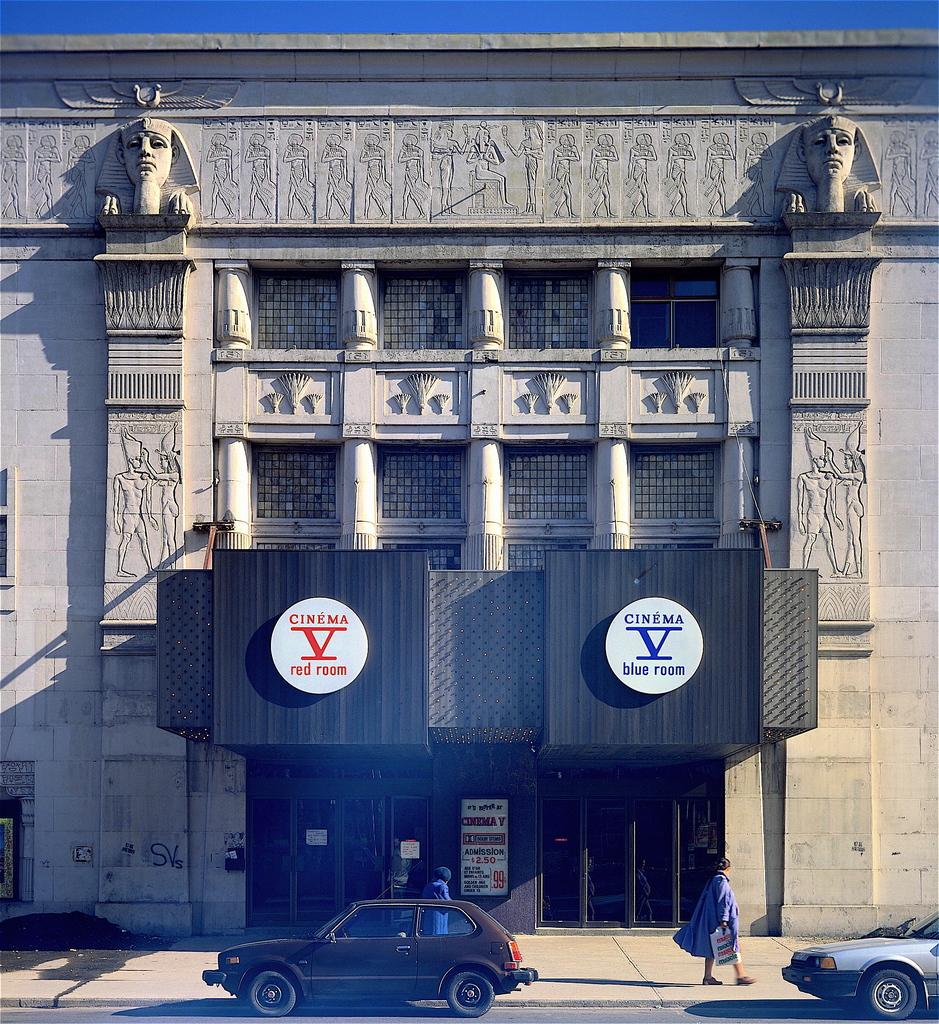What type of structure is visible in the image? There is a building in the image. What decorative elements can be seen on the building? The building has sculptures on its walls. Are there any people present in the image? Yes, there are two persons in front of the building. What else can be seen in front of the building? There are vehicles in front of the building. Can you tell me what the stranger is saying to the lawyer in the image? There is no stranger or lawyer present in the image. 